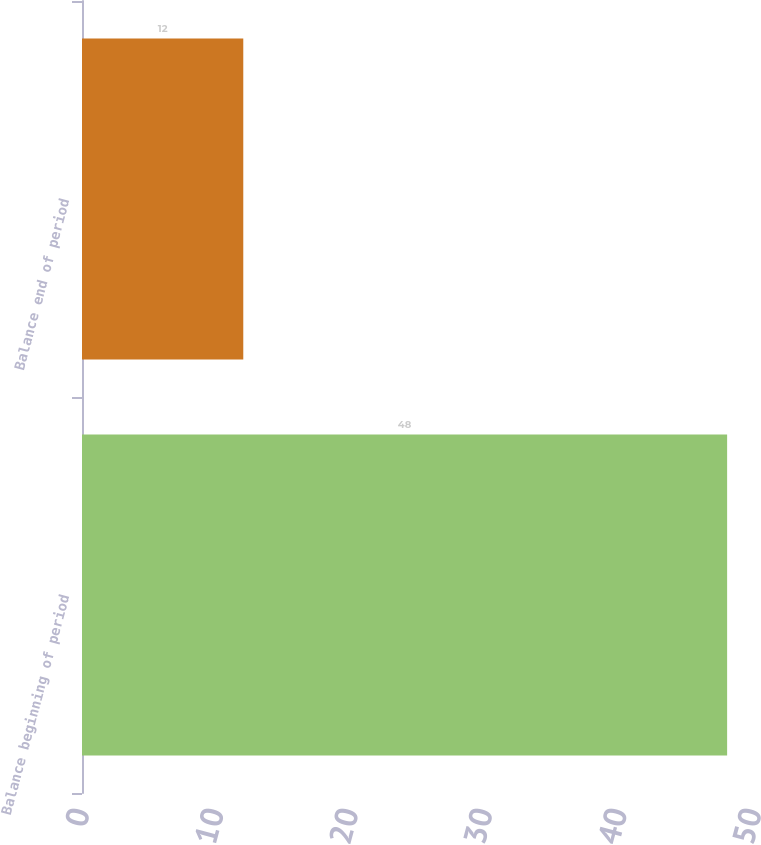Convert chart. <chart><loc_0><loc_0><loc_500><loc_500><bar_chart><fcel>Balance beginning of period<fcel>Balance end of period<nl><fcel>48<fcel>12<nl></chart> 